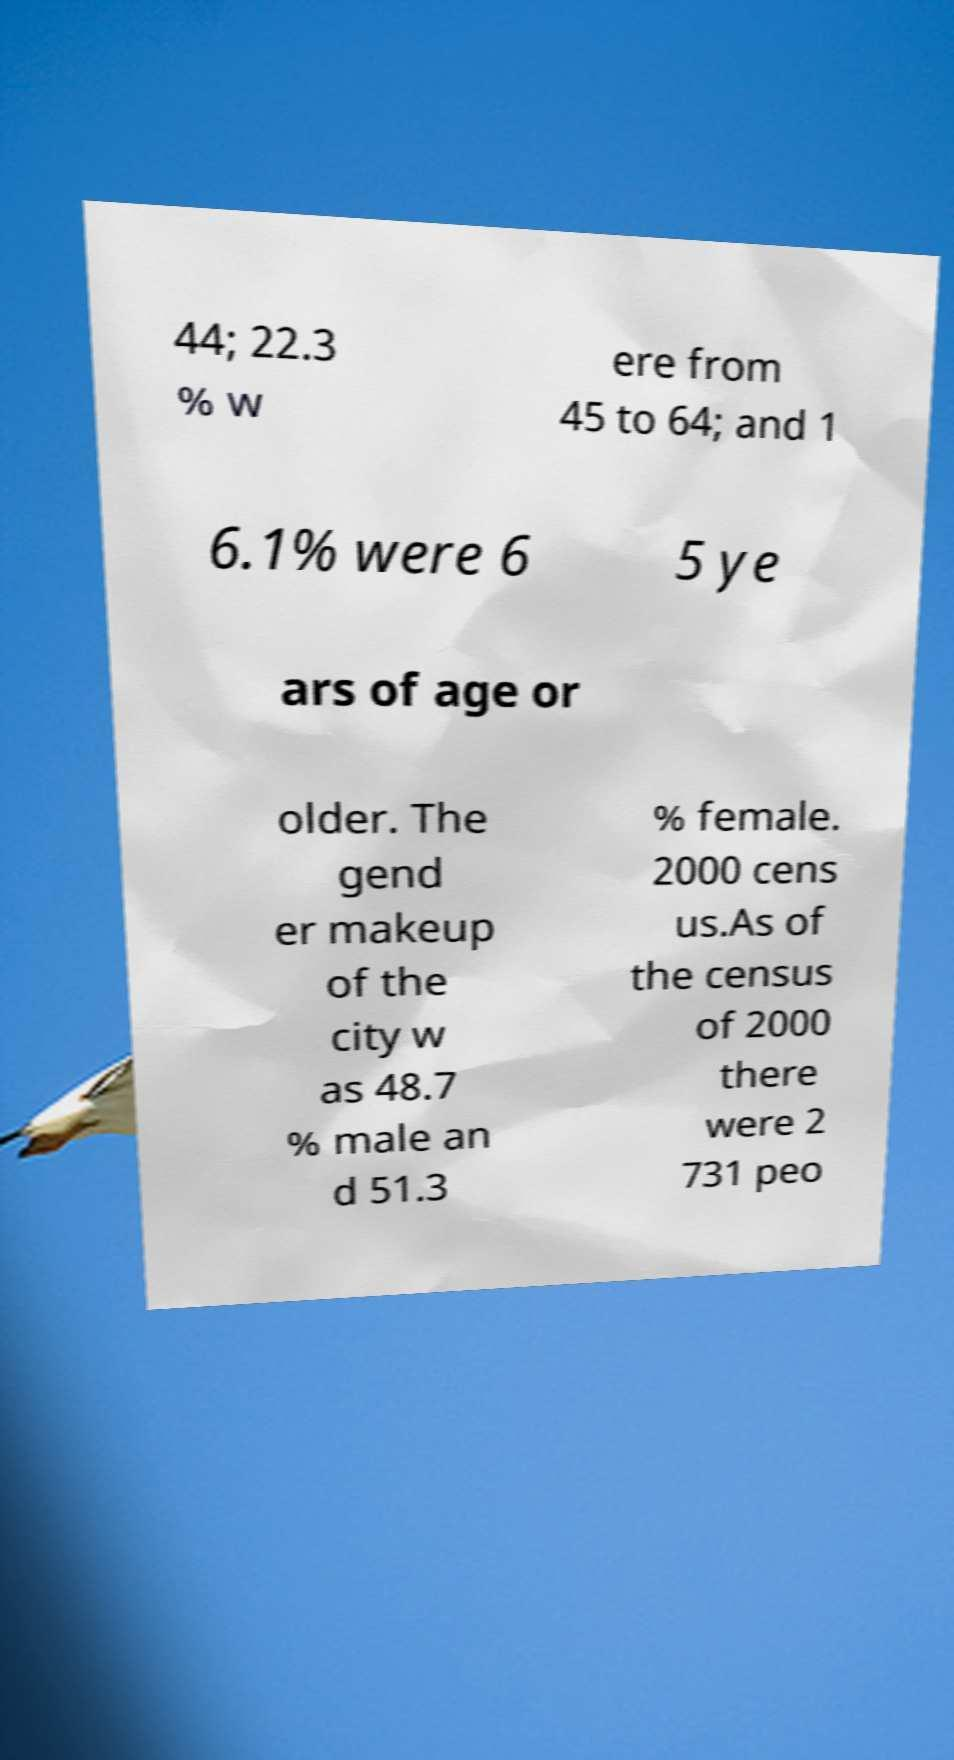Please identify and transcribe the text found in this image. 44; 22.3 % w ere from 45 to 64; and 1 6.1% were 6 5 ye ars of age or older. The gend er makeup of the city w as 48.7 % male an d 51.3 % female. 2000 cens us.As of the census of 2000 there were 2 731 peo 